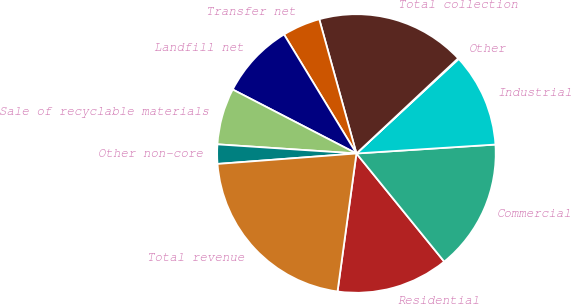Convert chart to OTSL. <chart><loc_0><loc_0><loc_500><loc_500><pie_chart><fcel>Residential<fcel>Commercial<fcel>Industrial<fcel>Other<fcel>Total collection<fcel>Transfer net<fcel>Landfill net<fcel>Sale of recyclable materials<fcel>Other non-core<fcel>Total revenue<nl><fcel>13.02%<fcel>15.17%<fcel>10.86%<fcel>0.09%<fcel>17.33%<fcel>4.4%<fcel>8.71%<fcel>6.55%<fcel>2.24%<fcel>21.64%<nl></chart> 